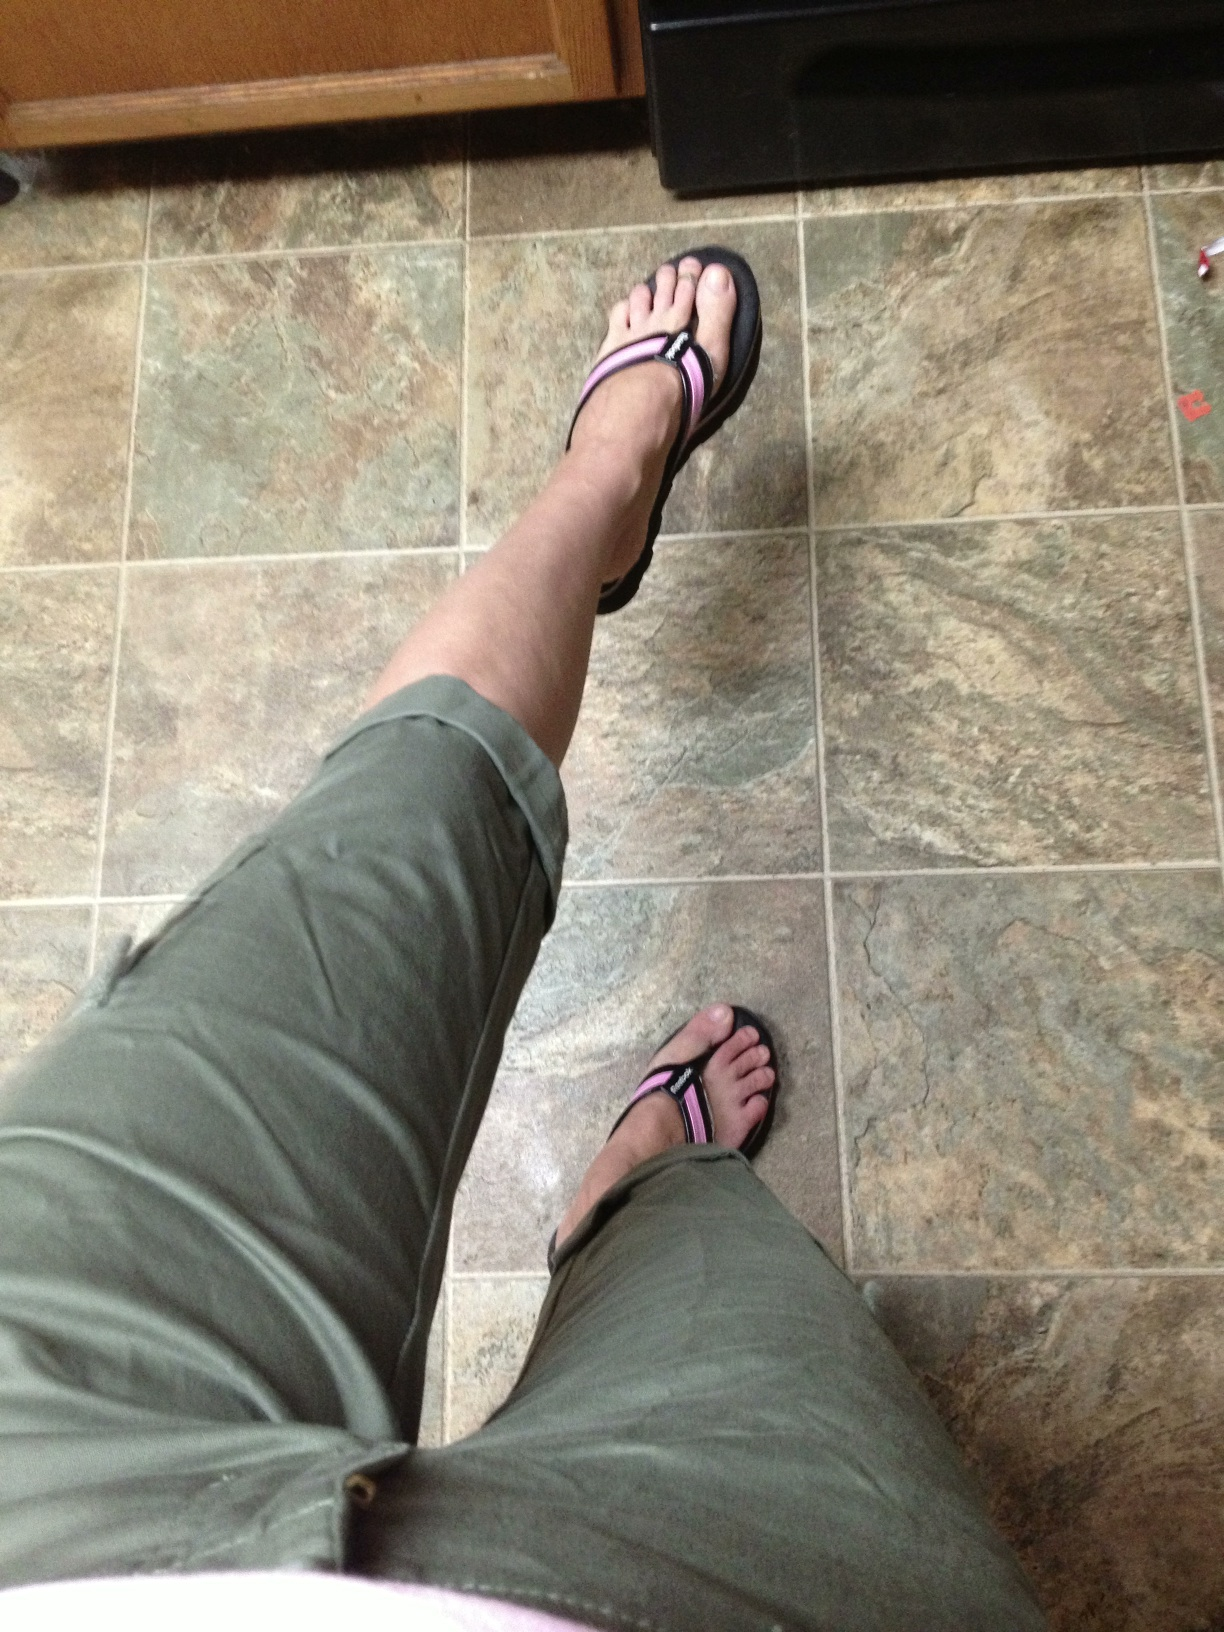Can you tell me what color the pants are that I'm wearing? They're just below the knee. I can't tell if they're- well I just don't know what color they are. The pants you're wearing are green. They appear to be a muted, earthy shade, which complements the casual style nicely. 